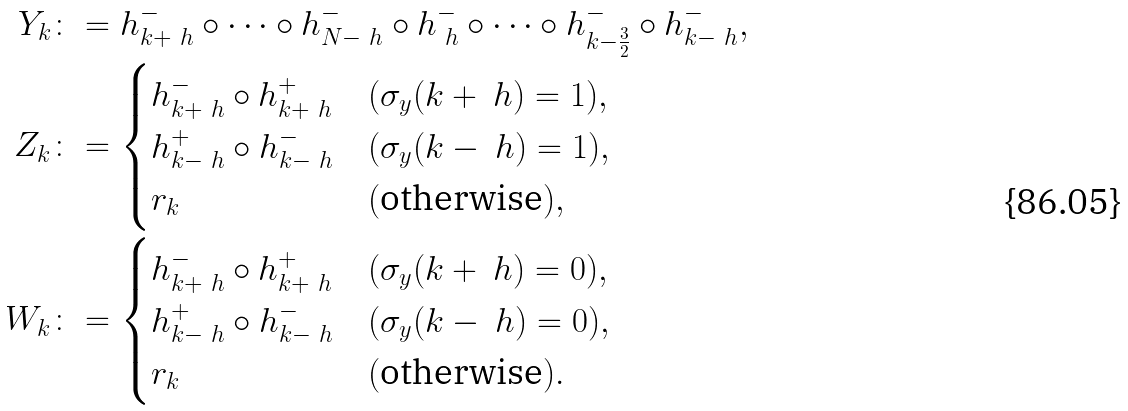Convert formula to latex. <formula><loc_0><loc_0><loc_500><loc_500>Y _ { k } & \colon = h ^ { - } _ { k + \ h } \circ \cdots \circ h ^ { - } _ { N - \ h } \circ h ^ { - } _ { \ h } \circ \cdots \circ h ^ { - } _ { k - \frac { 3 } { 2 } } \circ h ^ { - } _ { k - \ h } , \\ Z _ { k } & \colon = \begin{cases} h ^ { - } _ { k + \ h } \circ h ^ { + } _ { k + \ h } & ( \sigma _ { y } ( k + \ h ) = 1 ) , \\ h ^ { + } _ { k - \ h } \circ h ^ { - } _ { k - \ h } & ( \sigma _ { y } ( k - \ h ) = 1 ) , \\ r _ { k } & ( \text {otherwise} ) , \end{cases} \\ W _ { k } & \colon = \begin{cases} h ^ { - } _ { k + \ h } \circ h ^ { + } _ { k + \ h } & ( \sigma _ { y } ( k + \ h ) = 0 ) , \\ h ^ { + } _ { k - \ h } \circ h ^ { - } _ { k - \ h } & ( \sigma _ { y } ( k - \ h ) = 0 ) , \\ r _ { k } & ( \text {otherwise} ) . \end{cases}</formula> 